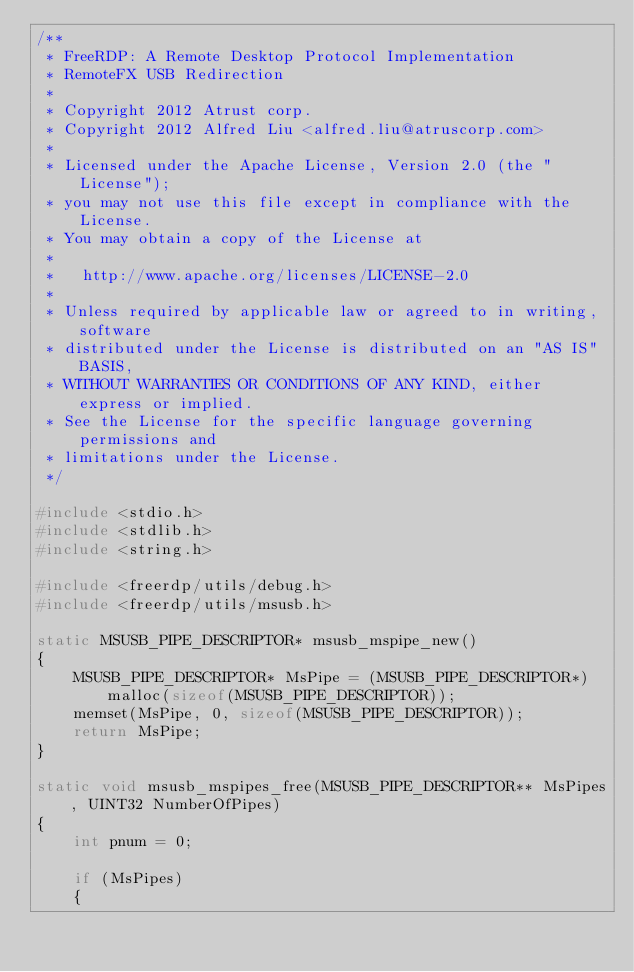Convert code to text. <code><loc_0><loc_0><loc_500><loc_500><_C_>/**
 * FreeRDP: A Remote Desktop Protocol Implementation
 * RemoteFX USB Redirection
 *
 * Copyright 2012 Atrust corp.
 * Copyright 2012 Alfred Liu <alfred.liu@atruscorp.com>
 *
 * Licensed under the Apache License, Version 2.0 (the "License");
 * you may not use this file except in compliance with the License.
 * You may obtain a copy of the License at
 *
 *	 http://www.apache.org/licenses/LICENSE-2.0
 *
 * Unless required by applicable law or agreed to in writing, software
 * distributed under the License is distributed on an "AS IS" BASIS,
 * WITHOUT WARRANTIES OR CONDITIONS OF ANY KIND, either express or implied.
 * See the License for the specific language governing permissions and
 * limitations under the License.
 */

#include <stdio.h>
#include <stdlib.h>
#include <string.h>

#include <freerdp/utils/debug.h>
#include <freerdp/utils/msusb.h>

static MSUSB_PIPE_DESCRIPTOR* msusb_mspipe_new()
{
	MSUSB_PIPE_DESCRIPTOR* MsPipe = (MSUSB_PIPE_DESCRIPTOR*) malloc(sizeof(MSUSB_PIPE_DESCRIPTOR));
	memset(MsPipe, 0, sizeof(MSUSB_PIPE_DESCRIPTOR));
	return MsPipe;
}

static void msusb_mspipes_free(MSUSB_PIPE_DESCRIPTOR** MsPipes, UINT32 NumberOfPipes)
{
	int pnum = 0;

	if (MsPipes)
	{</code> 